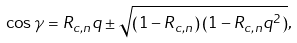<formula> <loc_0><loc_0><loc_500><loc_500>\cos \gamma = R _ { c , n } q \pm \sqrt { \left ( 1 - R _ { c , n } \right ) \left ( 1 - R _ { c , n } q ^ { 2 } \right ) } ,</formula> 